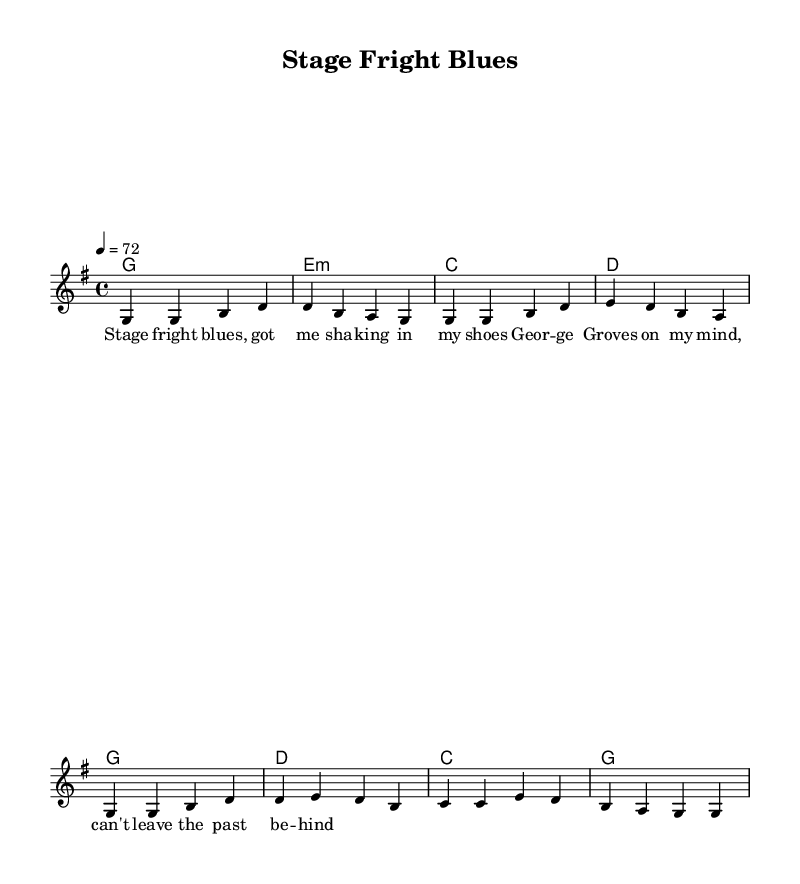What is the key signature of this music? The key signature is G major, as indicated by the presence of one sharp (F#) in the key signature at the beginning of the score, confirming it is in G major.
Answer: G major What is the time signature of the piece? The time signature is 4/4, as indicated by the "4/4" notation at the beginning of the score, signifying four beats per measure and a quarter note receives one beat.
Answer: 4/4 What is the tempo marking for this piece? The tempo marking is 72 beats per minute, indicated by the notation "4 = 72," meaning that the quarter note is played at a speed of seventy-two beats in one minute.
Answer: 72 How many measures are there in the verse section? There are four measures in the verse section, as the melody and harmonies labeled for the verse each consist of four distinct measures outlined in the score.
Answer: 4 Which chord is used in the last measure of the chorus? The last measure of the chorus uses the G major chord, indicated in the chord progression where the last chord is labeled as "g" in the harmonies following the symbol for that measure.
Answer: G What lyrical theme is explored in this piece? The lyrical theme deals with performance anxiety, as suggested by the title "Stage Fright Blues" and the lyrics which express feelings of nervousness and a rivalry with George Groves, indicative of performance-related stress.
Answer: Performance anxiety What is the structure of the piece? The structure consists of a verse followed by a chorus, as the sheet music is divided into sections labeled for both segments, showing a clear separation in the form of the music.
Answer: Verse-Chorus 